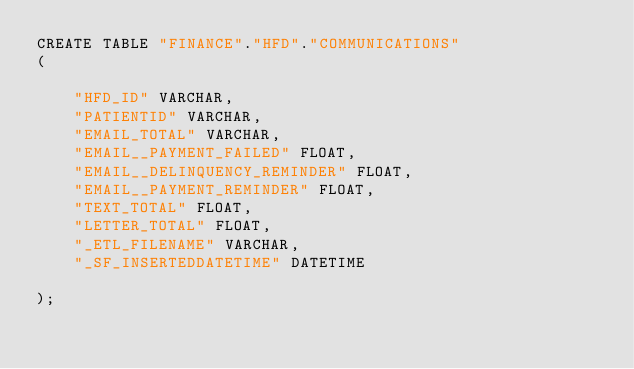Convert code to text. <code><loc_0><loc_0><loc_500><loc_500><_SQL_>CREATE TABLE "FINANCE"."HFD"."COMMUNICATIONS"
(

    "HFD_ID" VARCHAR,
    "PATIENTID" VARCHAR,
    "EMAIL_TOTAL" VARCHAR,
    "EMAIL__PAYMENT_FAILED" FLOAT,
    "EMAIL__DELINQUENCY_REMINDER" FLOAT,
    "EMAIL__PAYMENT_REMINDER" FLOAT,
    "TEXT_TOTAL" FLOAT,
    "LETTER_TOTAL" FLOAT,
    "_ETL_FILENAME" VARCHAR,
    "_SF_INSERTEDDATETIME" DATETIME

);
</code> 